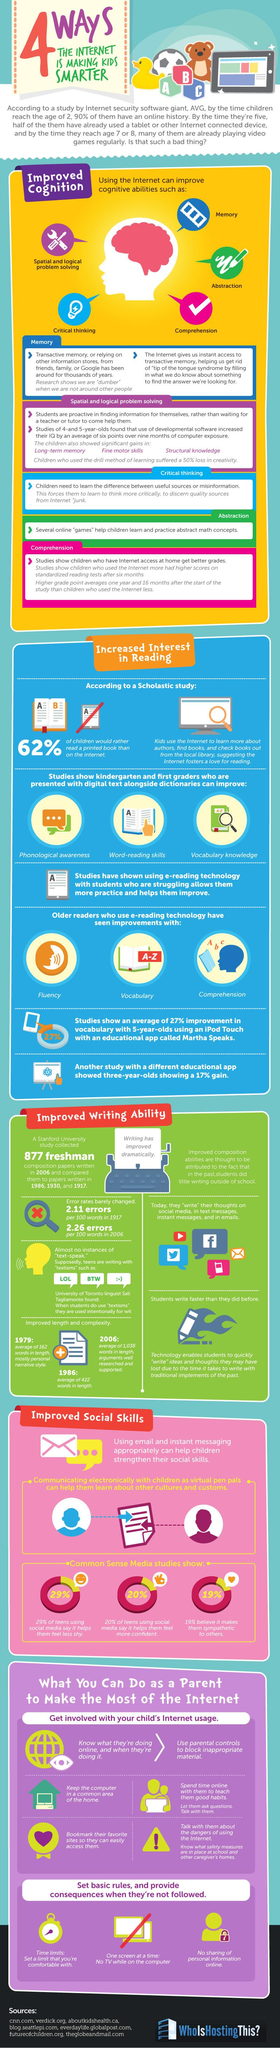Draw attention to some important aspects in this diagram. From 1979 to 1986, the average length of words increased by approximately 260 characters. Writing has dramatically improved, as is evident from the paper of the typewriter, which now prints a variety of texts that were not possible to produce before. The increase in errors per 100 words from 1917 to 2006 was approximately 0.15. The cubes beside the duck contain the letters A, B, C, and so on. In 2006, the composition papers from different years were compared, including 1986, 1939, and 1917. 